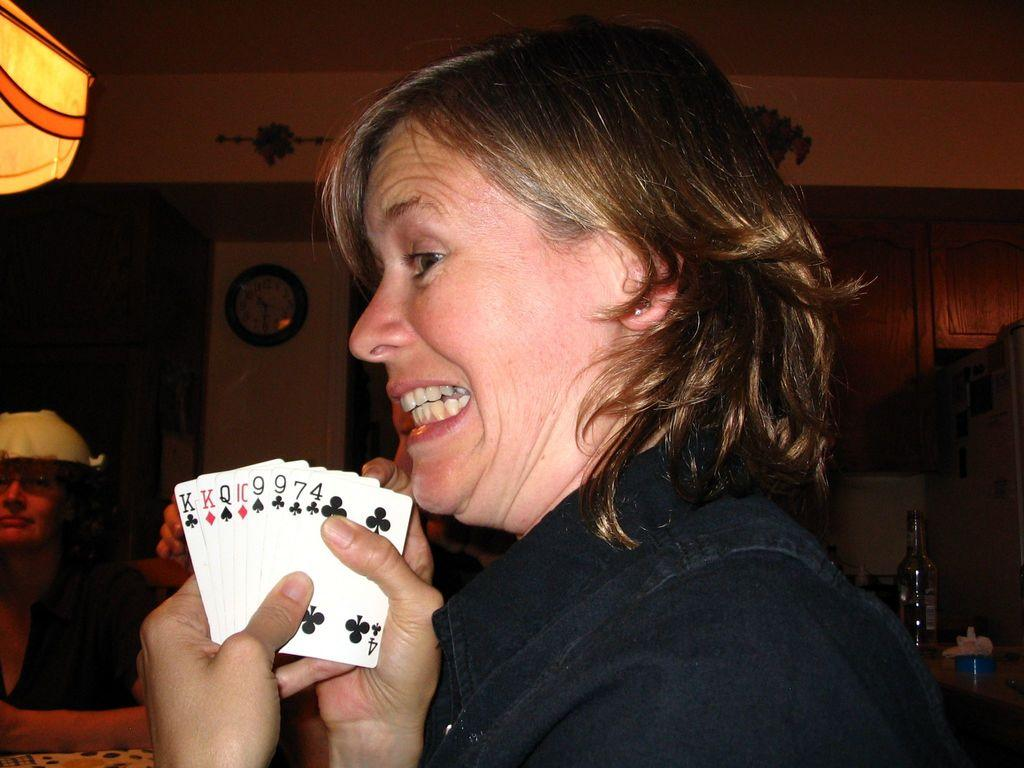Who is the main subject in the image? There is a woman in the image. What is the woman wearing? The woman is wearing a black coat. What is the woman holding in her hand? The woman is showing a white playing card. What is the woman doing in the image? The woman is posing for the camera. What can be seen in the background of the image? There is a yellow wall in the background, and there is a clock on the wall. How many boys are running along the edge of the yellow wall in the image? There are no boys present in the image, and the image does not show any running or edges. 